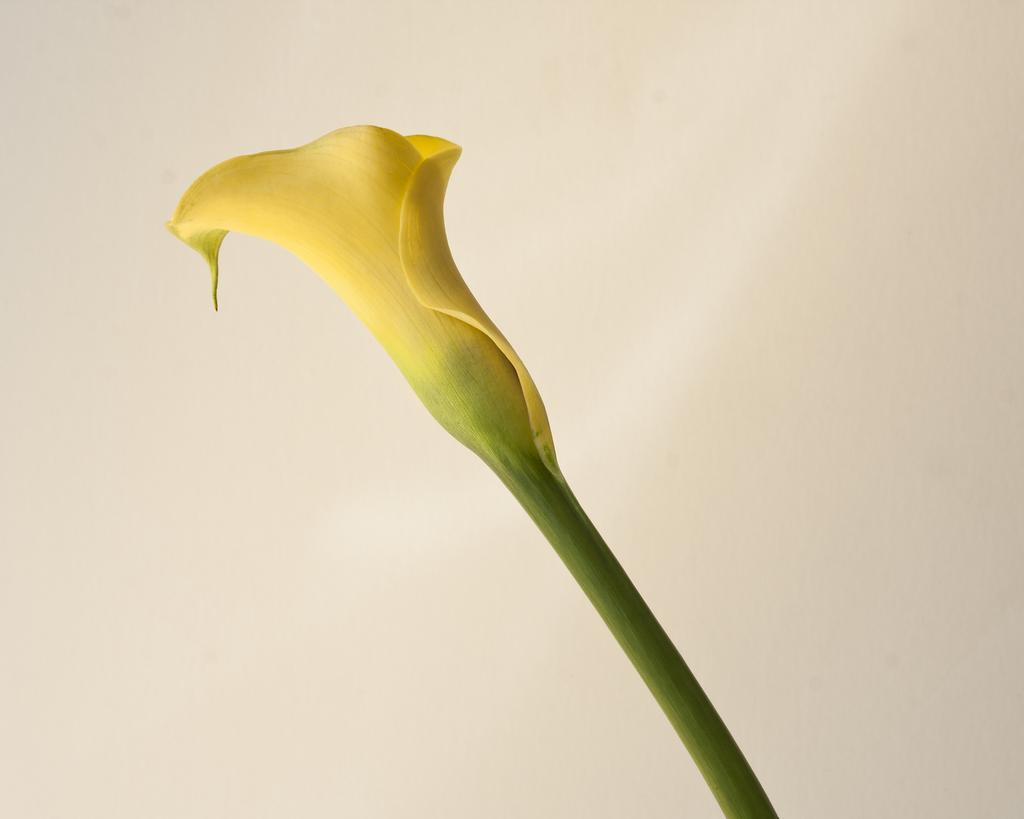What type of flower can be seen in the picture? There is a yellow flower in the picture. What can be seen in the background of the picture? There is a wall visible in the background of the picture. What type of brass instrument is being played in the picture? There is no brass instrument present in the picture; it only features a yellow flower and a wall in the background. 